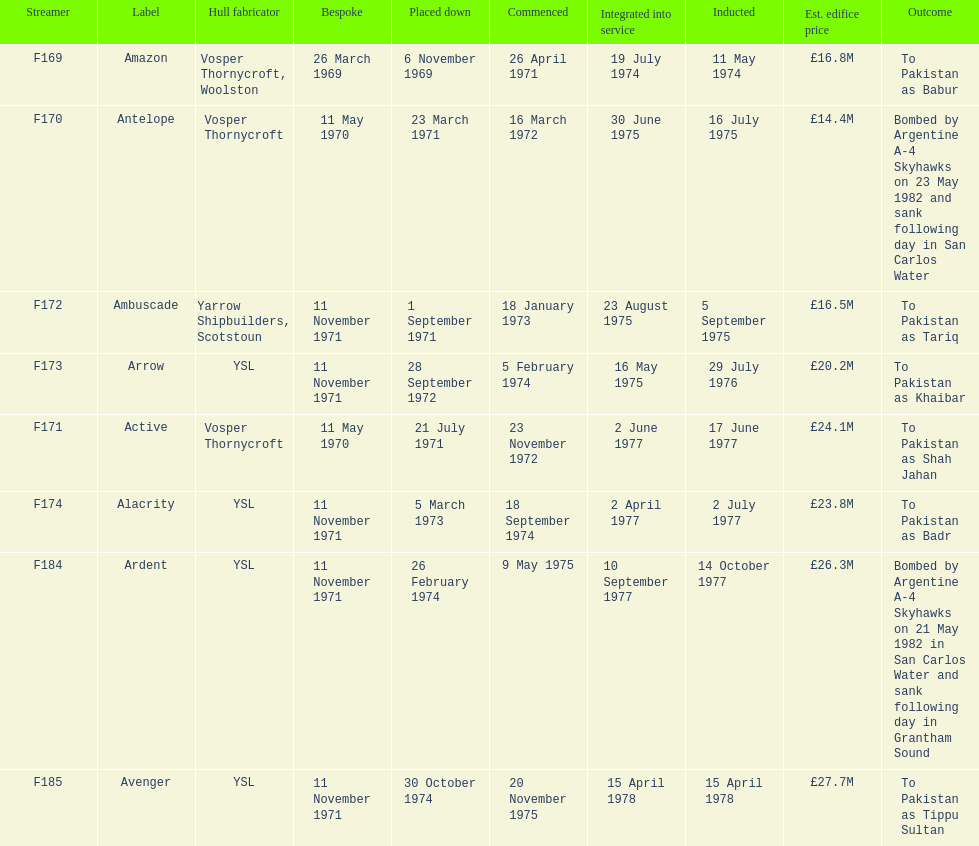Which ship had the highest estimated cost to build? Avenger. 